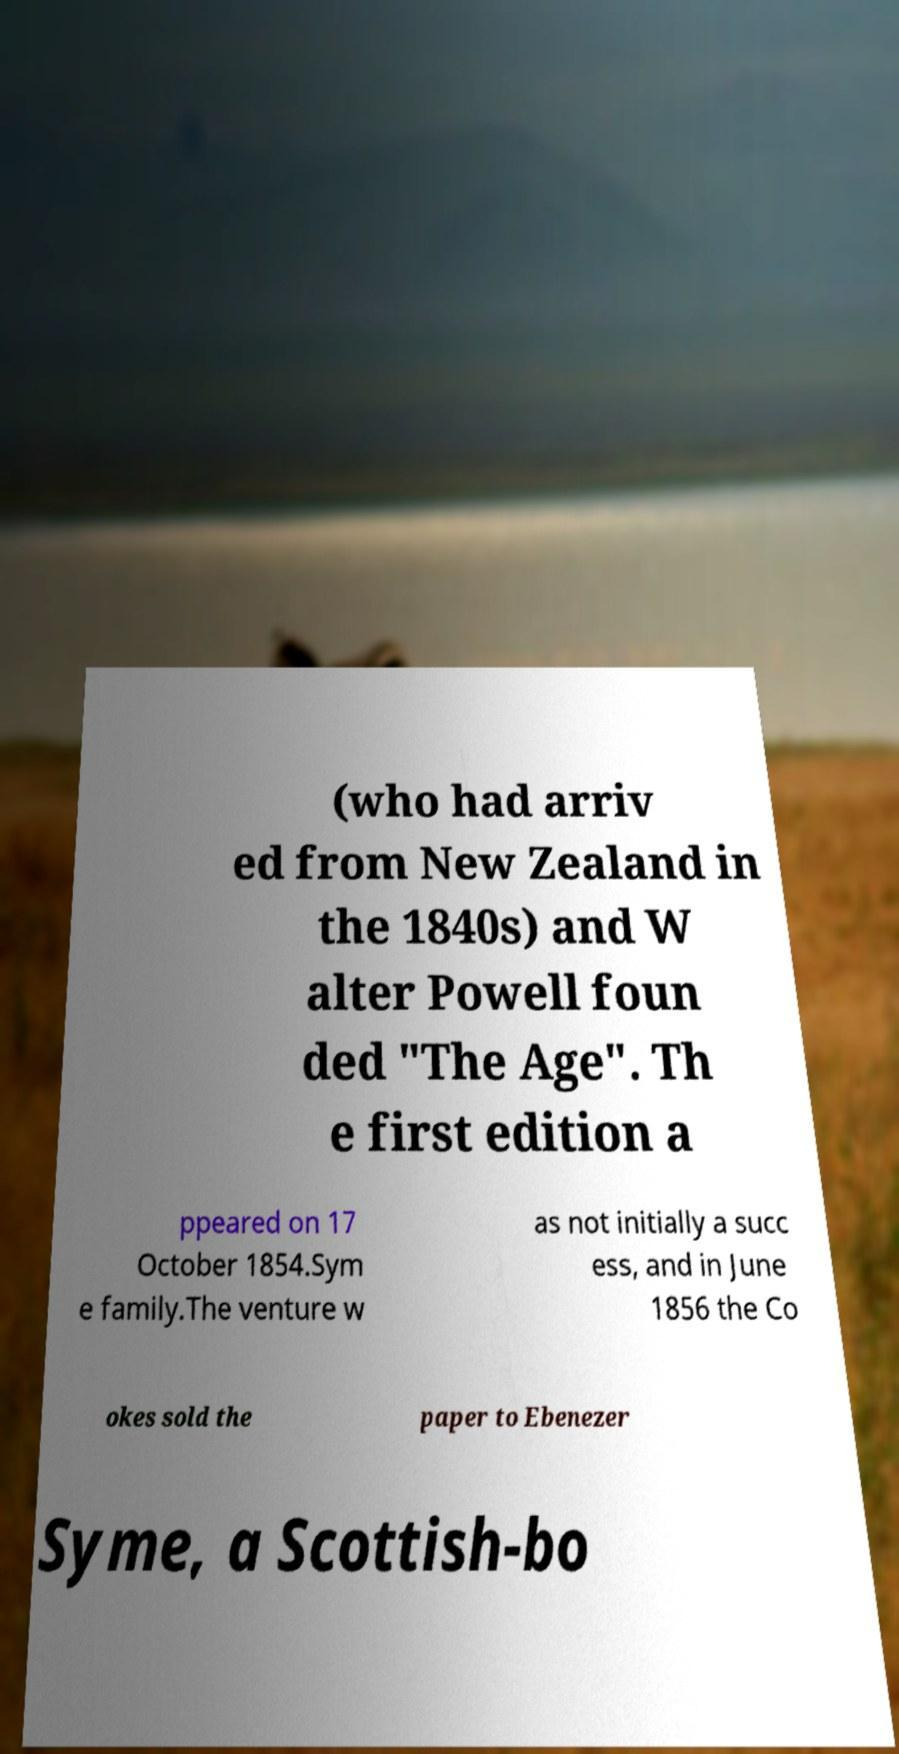What messages or text are displayed in this image? I need them in a readable, typed format. (who had arriv ed from New Zealand in the 1840s) and W alter Powell foun ded "The Age". Th e first edition a ppeared on 17 October 1854.Sym e family.The venture w as not initially a succ ess, and in June 1856 the Co okes sold the paper to Ebenezer Syme, a Scottish-bo 